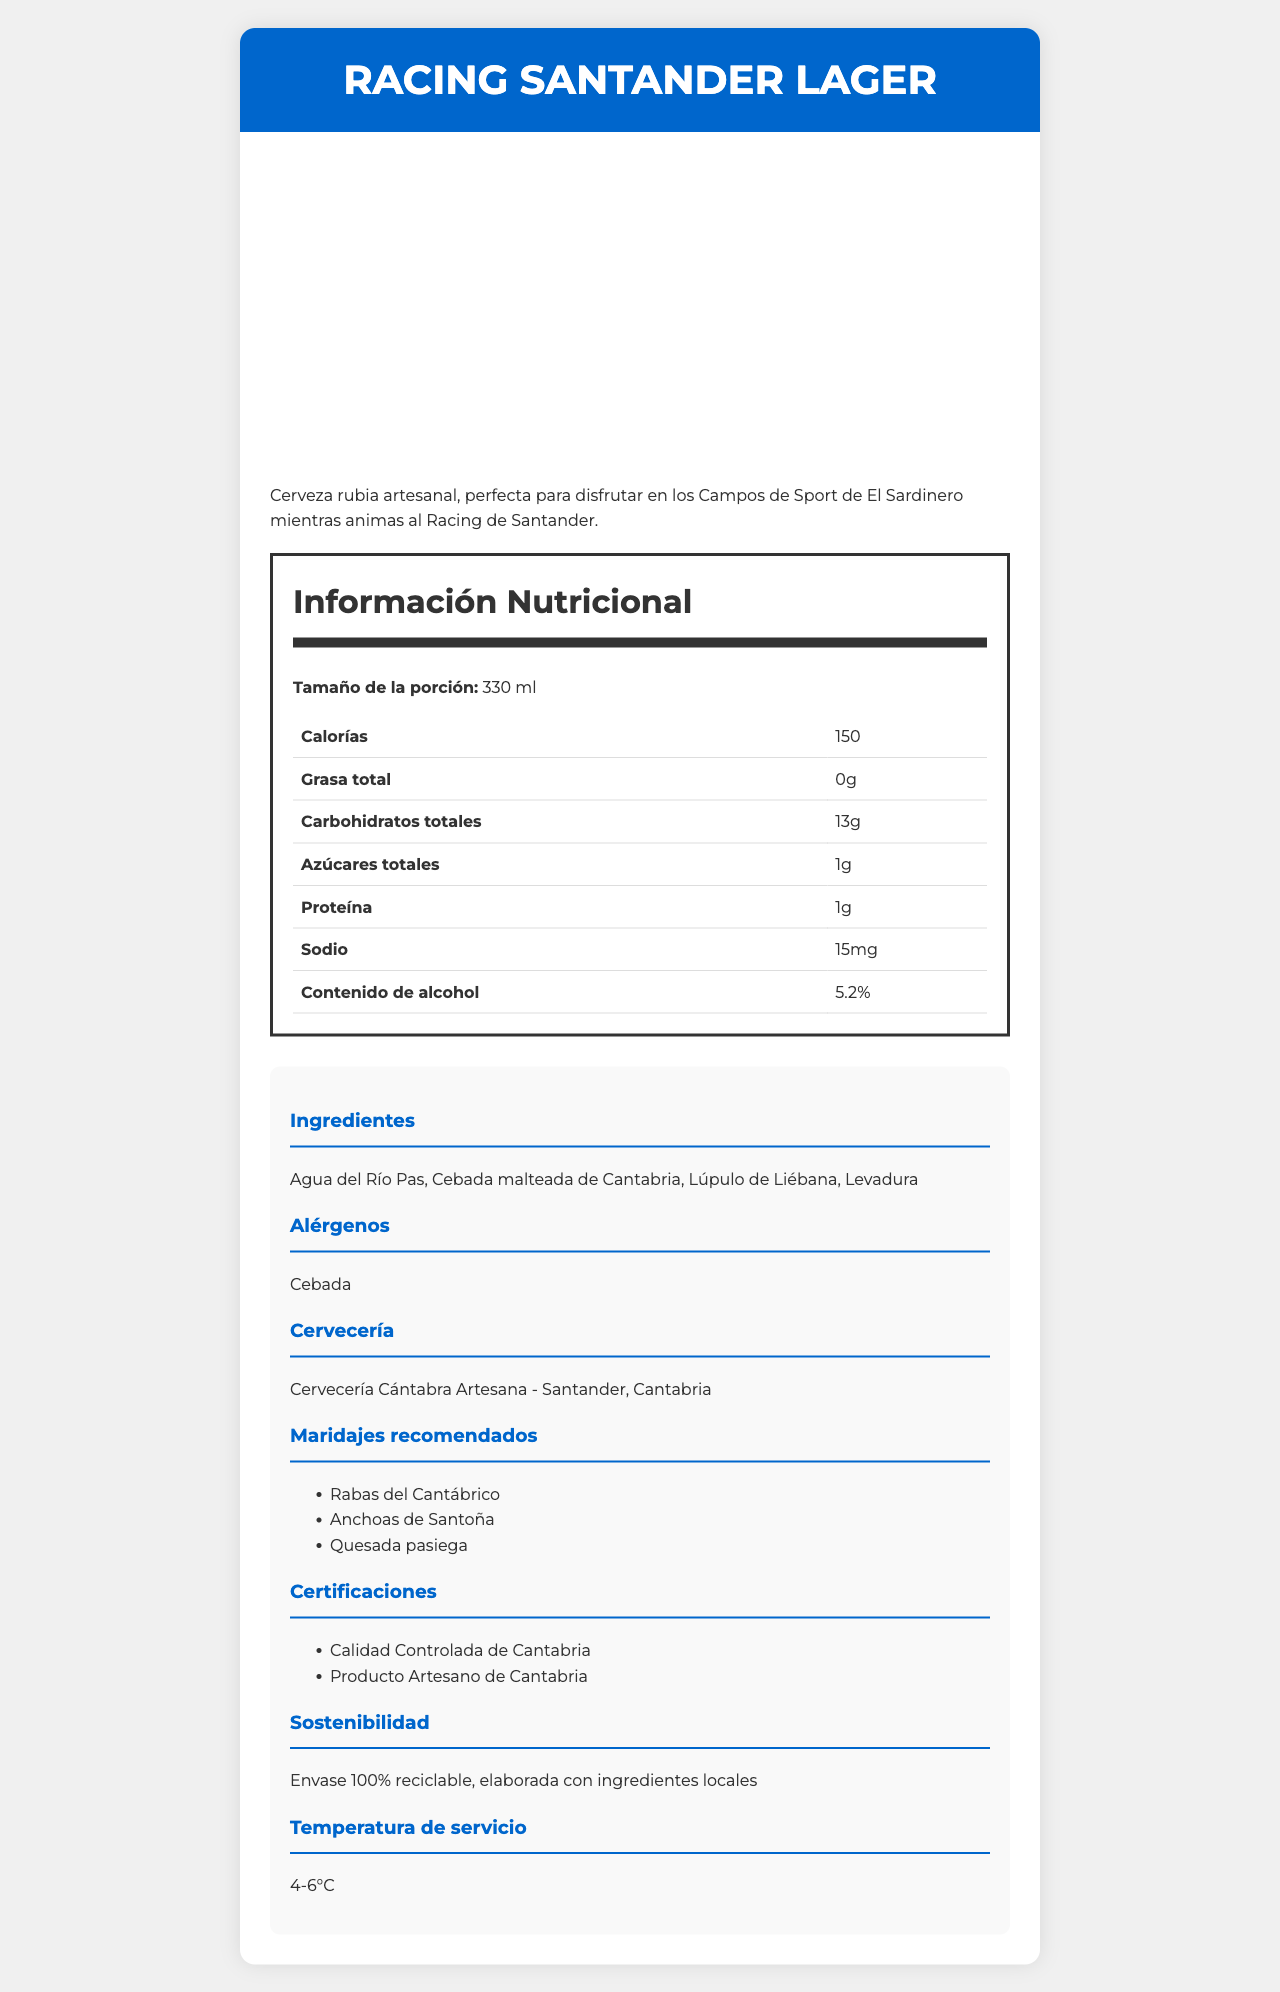what is the name of the beer? The name of the beer is stated clearly at the top of the document and multiple times throughout.
Answer: Racing Santander Lager what is the alcohol content of the beer? The alcohol content is mentioned in the nutrition facts section under "Contenido de alcohol".
Answer: 5.2% how many calories are in a serving of Racing Santander Lager? The calorie count is listed in the nutrition facts table under "Calorías".
Answer: 150 what is the serving size for this beer? The serving size is listed right at the top of the nutrition facts section as "Tamaño de la porción".
Answer: 330 ml how much protein does this beer contain? The protein content is listed in the nutrition facts table under "Proteína".
Answer: 1g where is the brewery located? The brewery location is listed under the "Cervecería" section.
Answer: Santander, Cantabria what allergens are present in Racing Santander Lager? The allergens are listed under the "Alérgenos" section.
Answer: Cebada which ingredient is not used in Racing Santander Lager? A. Agua del Río Pas B. Lúpulo de Liébana C. Azúcar refinado The ingredients listed are "Agua del Río Pas", "Cebada malteada de Cantabria", "Lúpulo de Liébana", and "Levadura". Azúcar refinado is not listed.
Answer: C. Azúcar refinado how much sodium is in a serving? A. 10mg B. 15mg C. 20mg The sodium content is listed in the nutrition facts table under "Sodio" as 15mg.
Answer: B. 15mg is Racing Santander Lager suitable for someone avoiding gluten? The allergen listed is "Cebada" (barley), which contains gluten.
Answer: No summarize the main idea of the document The document provides comprehensive details on the nutritional facts, ingredients, allergens, and certifications for Racing Santander Lager, emphasizing its local origin and suitability for football enthusiasts.
Answer: Racing Santander Lager is a locally crafted beer from Santander, Cantabria, with a 5.2% alcohol content, ideal for enjoying during football matches. It has a serving size of 330 ml and contains 150 calories, 1g of protein, and 15mg of sodium per serving. The beer boasts local ingredients and various certifications, and it is advised to be served at 4-6°C. what are some recommended food pairings for this beer? The recommended food pairings are listed under the "Maridajes recomendados" section.
Answer: Rabas del Cantábrico, Anchoas de Santoña, Quesada pasiega what is the total fat content in Racing Santander Lager? The total fat content is listed in the nutrition facts table under "Grasa total".
Answer: 0g which certifications does this beer have? The certifications are listed under the "Certificaciones" section.
Answer: Calidad Controlada de Cantabria, Producto Artesano de Cantabria what kind of hops is used in this beer? The type of hops used is listed in the ingredients section as "Lúpulo de Liébana".
Answer: Lúpulo de Liébana does this beer contain any dietary fiber? The dietary fiber content is listed as 0g in the nutrition facts table.
Answer: No what is the brewing company for Racing Santander Lager? The brewing company is listed under the "Cervecería" section.
Answer: Cervecería Cántabra Artesana does the beer contain any Vitamin D? The nutrition facts table shows that there is 0g of Vitamin D.
Answer: No from which water source is the beer made? The water source is mentioned in the ingredients list as "Agua del Río Pas".
Answer: Agua del Río Pas does the label provide information on whether the beer is suitable for vegetarians? The label does not explicitly state if the beer is suitable for vegetarians.
Answer: Not enough information 